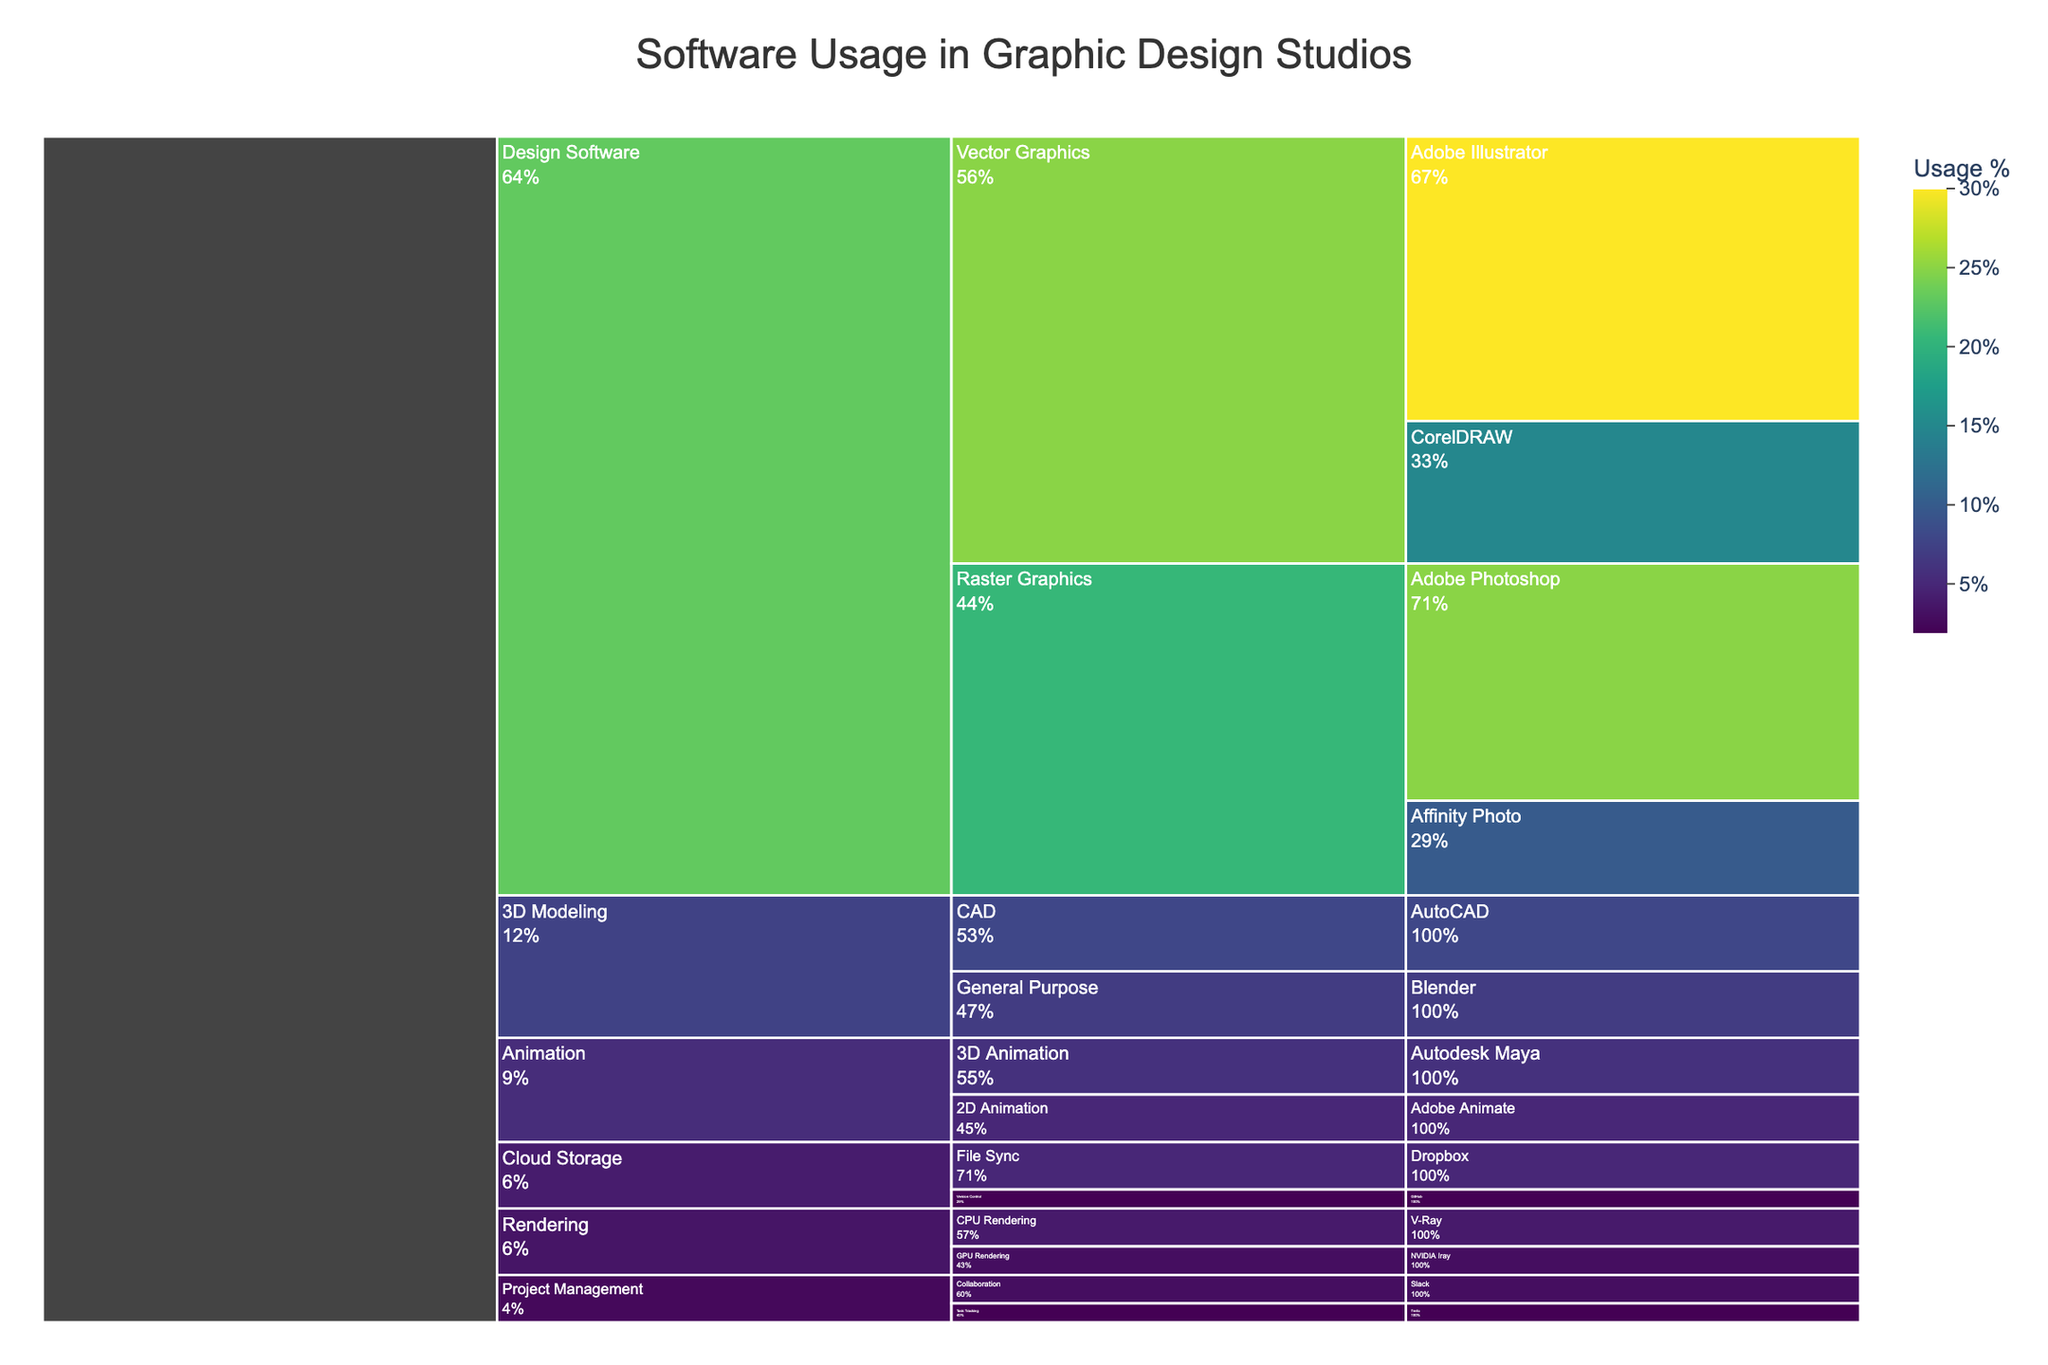What is the title of the icicle chart? The title of a figure is usually found at the top. This chart's title clarifies the overall topic being depicted.
Answer: Software Usage in Graphic Design Studios What is the most used Vector Graphics application? Look for the Vector Graphics section under Design Software and identify the application with the highest usage percentage.
Answer: Adobe Illustrator Which category has the smallest usage percentage overall? Sum the usage percentages of all subcategories and applications under each main category, and compare to find the smallest total value.
Answer: Project Management How does the usage percentage of Adobe Photoshop compare to Affinity Photo? Both applications fall under Raster Graphics under Design Software. Compare the values directly.
Answer: Adobe Photoshop has 25% while Affinity Photo has 10%, so Adobe Photoshop is used more What is the combined usage percentage of all 3D Modeling applications? Add the usage percentages of AutoCAD (8%) and Blender (7%) under the 3D Modeling category.
Answer: 15% Which application has the lowest usage percentage? Scan through the usage percentages of all applications to find the minimum value.
Answer: Trello or GitHub Is the overall usage percentage higher for Rendering or for Animation software? Add up the usage percentages of all applications under Rendering (V-Ray 4% and NVIDIA Iray 3%) and Animation (Adobe Animate 5% and Autodesk Maya 6%) categories, and compare the sums.
Answer: Rendering is lower with 7% compared to Animation which has 11% What is the usage percentage of CPU Rendering versus GPU Rendering applications? Check the values under the Rendering category: V-Ray for CPU Rendering (4%) and NVIDIA Iray for GPU Rendering (3%).
Answer: CPU Rendering: 4%, GPU Rendering: 3% Between Vector Graphics and Raster Graphics, which subcategory has a larger total usage? Sum the percentages for each subcategory: Vector Graphics (Adobe Illustrator 30% + CorelDRAW 15%) and Raster Graphics (Adobe Photoshop 25% + Affinity Photo 10%), and compare the totals.
Answer: Vector Graphics: 45%, Raster Graphics: 35% How is the color scale represented in the chart? The color scale typically uses a gradient to represent different values. In this chart, it uses the Viridis color scale, indicated by lighter to darker shades.
Answer: Viridis gradient from light to dark 